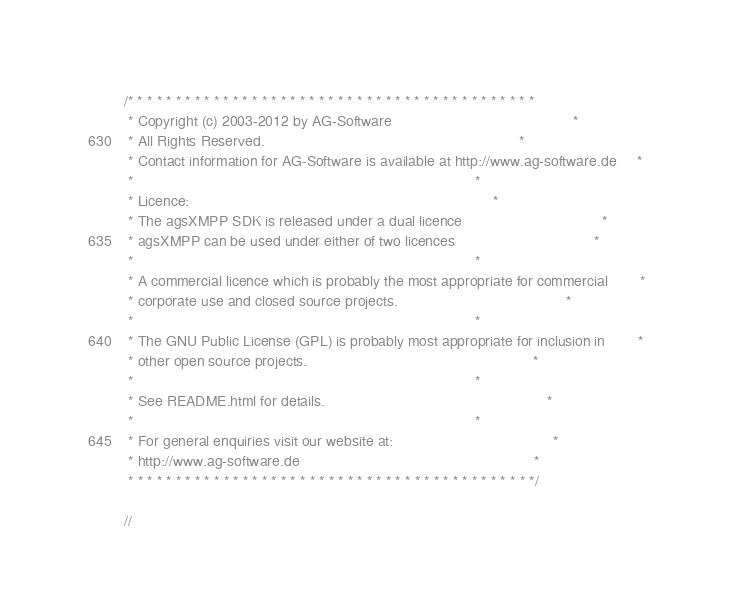Convert code to text. <code><loc_0><loc_0><loc_500><loc_500><_C#_>/* * * * * * * * * * * * * * * * * * * * * * * * * * * * * * * * * * * * * * * * * * *
 * Copyright (c) 2003-2012 by AG-Software 											 *
 * All Rights Reserved.																 *
 * Contact information for AG-Software is available at http://www.ag-software.de	 *
 *																					 *
 * Licence:																			 *
 * The agsXMPP SDK is released under a dual licence									 *
 * agsXMPP can be used under either of two licences									 *
 * 																					 *
 * A commercial licence which is probably the most appropriate for commercial 		 *
 * corporate use and closed source projects. 										 *
 *																					 *
 * The GNU Public License (GPL) is probably most appropriate for inclusion in		 *
 * other open source projects.														 *
 *																					 *
 * See README.html for details.														 *
 *																					 *
 * For general enquiries visit our website at:										 *
 * http://www.ag-software.de														 *
 * * * * * * * * * * * * * * * * * * * * * * * * * * * * * * * * * * * * * * * * * * */

//</code> 